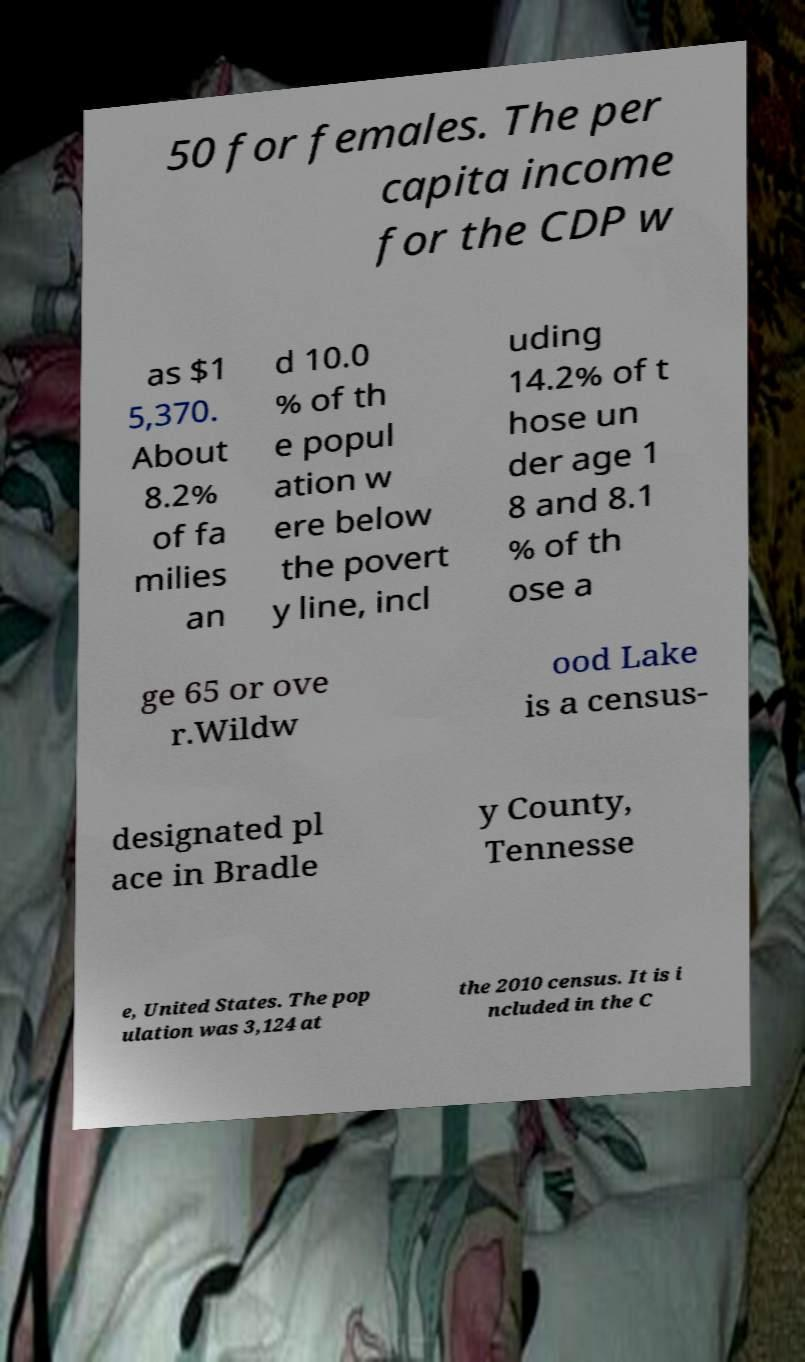I need the written content from this picture converted into text. Can you do that? 50 for females. The per capita income for the CDP w as $1 5,370. About 8.2% of fa milies an d 10.0 % of th e popul ation w ere below the povert y line, incl uding 14.2% of t hose un der age 1 8 and 8.1 % of th ose a ge 65 or ove r.Wildw ood Lake is a census- designated pl ace in Bradle y County, Tennesse e, United States. The pop ulation was 3,124 at the 2010 census. It is i ncluded in the C 